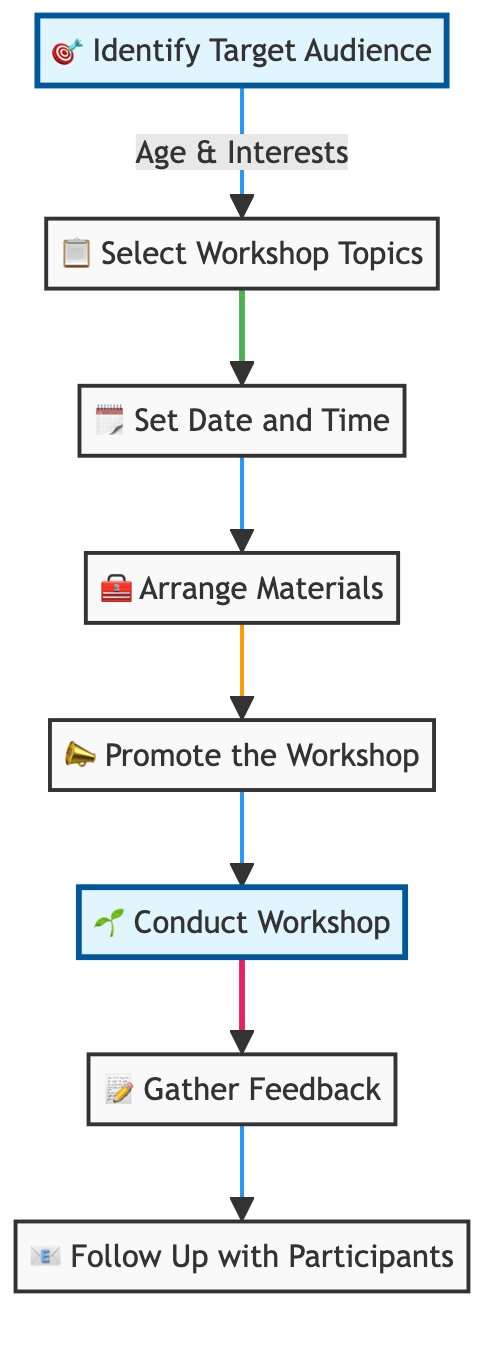What is the first step in the workshop process? The first step is to "Identify Target Audience." This is indicated as the starting point in the flowchart, shown at the top of the diagram and represented by the first node.
Answer: Identify Target Audience How many total steps are there in the process? By counting the number of nodes in the diagram, we see that there are eight distinct steps outlined from identifying the audience to following up with participants.
Answer: Eight Which step comes after promoting the workshop? The step that follows promoting the workshop is "Conduct Workshop," as indicated by the directed arrow leading from the node labeled 'Promote the Workshop' to 'Conduct Workshop.'
Answer: Conduct Workshop What are the materials to be arranged? The materials include pots, soil, seeds, and tools, as specified in the description of the node "Arrange Materials."
Answer: Pots, soil, seeds, tools What feedback is gathered after the workshop? After conducting the workshop, the step asks to "Gather Feedback," which involves collecting participant responses to improve future workshops.
Answer: Gather Feedback What two steps are highlighted in the flowchart? The two highlighted steps in the flowchart are "Identify Target Audience" and "Conduct Workshop." Highlighting signifies particular importance in these steps within the overall process.
Answer: Identify Target Audience, Conduct Workshop What is the purpose of following up with participants? The purpose is to send thank-you notes and additional resources for plant care, which is stated in the description of the last node "Follow Up with Participants."
Answer: Thank-you notes and additional resources How does the feedback influence future workshops? The feedback gathered helps in improving future workshops, as indicated in the description, emphasizing the iterative nature of the workshop planning process based on participant input.
Answer: Improve future workshops 